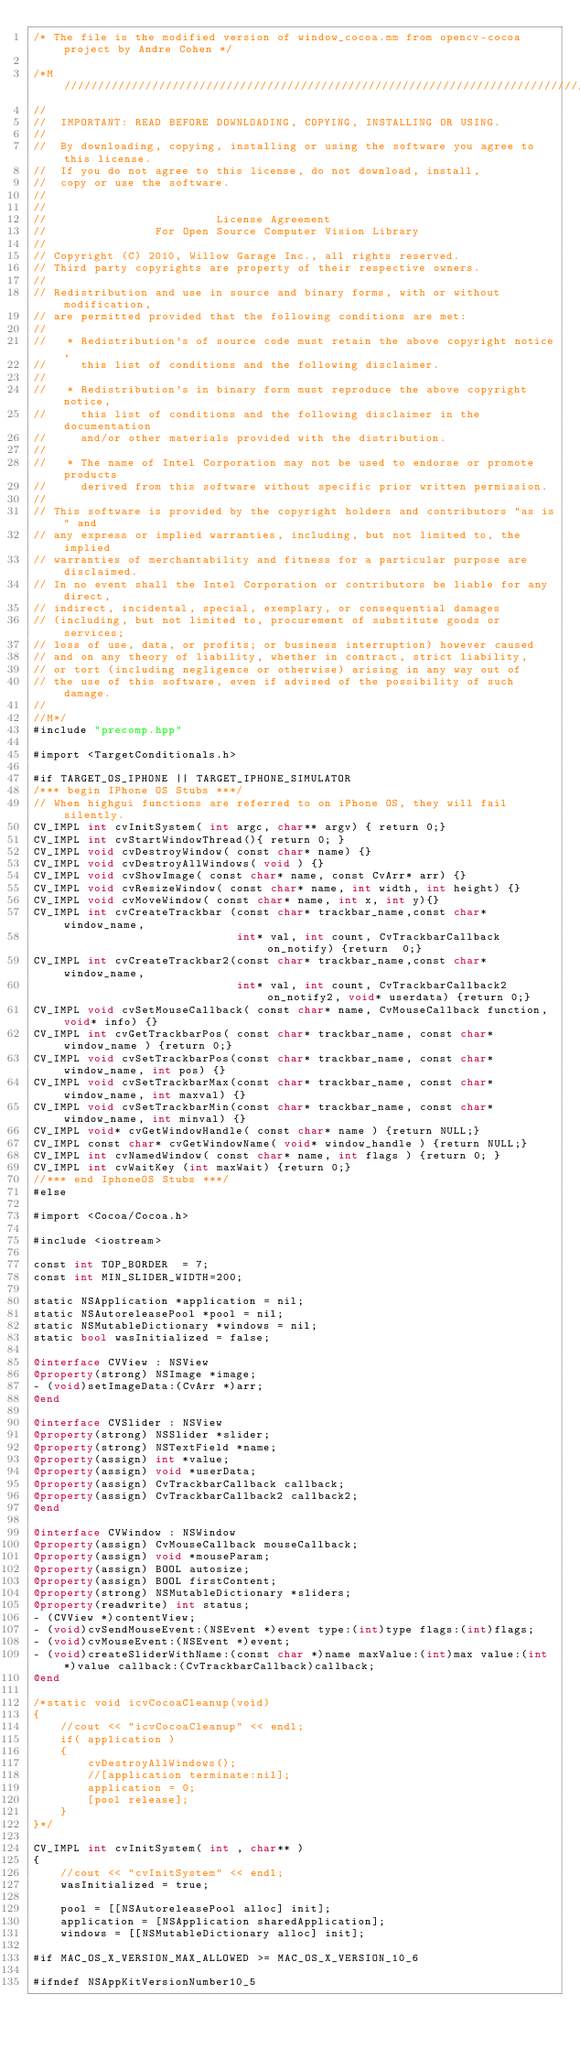<code> <loc_0><loc_0><loc_500><loc_500><_ObjectiveC_>/* The file is the modified version of window_cocoa.mm from opencv-cocoa project by Andre Cohen */

/*M///////////////////////////////////////////////////////////////////////////////////////
//
//  IMPORTANT: READ BEFORE DOWNLOADING, COPYING, INSTALLING OR USING.
//
//  By downloading, copying, installing or using the software you agree to this license.
//  If you do not agree to this license, do not download, install,
//  copy or use the software.
//
//
//                         License Agreement
//                For Open Source Computer Vision Library
//
// Copyright (C) 2010, Willow Garage Inc., all rights reserved.
// Third party copyrights are property of their respective owners.
//
// Redistribution and use in source and binary forms, with or without modification,
// are permitted provided that the following conditions are met:
//
//   * Redistribution's of source code must retain the above copyright notice,
//     this list of conditions and the following disclaimer.
//
//   * Redistribution's in binary form must reproduce the above copyright notice,
//     this list of conditions and the following disclaimer in the documentation
//     and/or other materials provided with the distribution.
//
//   * The name of Intel Corporation may not be used to endorse or promote products
//     derived from this software without specific prior written permission.
//
// This software is provided by the copyright holders and contributors "as is" and
// any express or implied warranties, including, but not limited to, the implied
// warranties of merchantability and fitness for a particular purpose are disclaimed.
// In no event shall the Intel Corporation or contributors be liable for any direct,
// indirect, incidental, special, exemplary, or consequential damages
// (including, but not limited to, procurement of substitute goods or services;
// loss of use, data, or profits; or business interruption) however caused
// and on any theory of liability, whether in contract, strict liability,
// or tort (including negligence or otherwise) arising in any way out of
// the use of this software, even if advised of the possibility of such damage.
//
//M*/
#include "precomp.hpp"

#import <TargetConditionals.h>

#if TARGET_OS_IPHONE || TARGET_IPHONE_SIMULATOR
/*** begin IPhone OS Stubs ***/
// When highgui functions are referred to on iPhone OS, they will fail silently.
CV_IMPL int cvInitSystem( int argc, char** argv) { return 0;}
CV_IMPL int cvStartWindowThread(){ return 0; }
CV_IMPL void cvDestroyWindow( const char* name) {}
CV_IMPL void cvDestroyAllWindows( void ) {}
CV_IMPL void cvShowImage( const char* name, const CvArr* arr) {}
CV_IMPL void cvResizeWindow( const char* name, int width, int height) {}
CV_IMPL void cvMoveWindow( const char* name, int x, int y){}
CV_IMPL int cvCreateTrackbar (const char* trackbar_name,const char* window_name,
                              int* val, int count, CvTrackbarCallback on_notify) {return  0;}
CV_IMPL int cvCreateTrackbar2(const char* trackbar_name,const char* window_name,
                              int* val, int count, CvTrackbarCallback2 on_notify2, void* userdata) {return 0;}
CV_IMPL void cvSetMouseCallback( const char* name, CvMouseCallback function, void* info) {}
CV_IMPL int cvGetTrackbarPos( const char* trackbar_name, const char* window_name ) {return 0;}
CV_IMPL void cvSetTrackbarPos(const char* trackbar_name, const char* window_name, int pos) {}
CV_IMPL void cvSetTrackbarMax(const char* trackbar_name, const char* window_name, int maxval) {}
CV_IMPL void cvSetTrackbarMin(const char* trackbar_name, const char* window_name, int minval) {}
CV_IMPL void* cvGetWindowHandle( const char* name ) {return NULL;}
CV_IMPL const char* cvGetWindowName( void* window_handle ) {return NULL;}
CV_IMPL int cvNamedWindow( const char* name, int flags ) {return 0; }
CV_IMPL int cvWaitKey (int maxWait) {return 0;}
//*** end IphoneOS Stubs ***/
#else

#import <Cocoa/Cocoa.h>

#include <iostream>

const int TOP_BORDER  = 7;
const int MIN_SLIDER_WIDTH=200;

static NSApplication *application = nil;
static NSAutoreleasePool *pool = nil;
static NSMutableDictionary *windows = nil;
static bool wasInitialized = false;

@interface CVView : NSView
@property(strong) NSImage *image;
- (void)setImageData:(CvArr *)arr;
@end

@interface CVSlider : NSView
@property(strong) NSSlider *slider;
@property(strong) NSTextField *name;
@property(assign) int *value;
@property(assign) void *userData;
@property(assign) CvTrackbarCallback callback;
@property(assign) CvTrackbarCallback2 callback2;
@end

@interface CVWindow : NSWindow
@property(assign) CvMouseCallback mouseCallback;
@property(assign) void *mouseParam;
@property(assign) BOOL autosize;
@property(assign) BOOL firstContent;
@property(strong) NSMutableDictionary *sliders;
@property(readwrite) int status;
- (CVView *)contentView;
- (void)cvSendMouseEvent:(NSEvent *)event type:(int)type flags:(int)flags;
- (void)cvMouseEvent:(NSEvent *)event;
- (void)createSliderWithName:(const char *)name maxValue:(int)max value:(int *)value callback:(CvTrackbarCallback)callback;
@end

/*static void icvCocoaCleanup(void)
{
    //cout << "icvCocoaCleanup" << endl;
    if( application )
    {
        cvDestroyAllWindows();
        //[application terminate:nil];
        application = 0;
        [pool release];
    }
}*/

CV_IMPL int cvInitSystem( int , char** )
{
    //cout << "cvInitSystem" << endl;
    wasInitialized = true;

    pool = [[NSAutoreleasePool alloc] init];
    application = [NSApplication sharedApplication];
    windows = [[NSMutableDictionary alloc] init];

#if MAC_OS_X_VERSION_MAX_ALLOWED >= MAC_OS_X_VERSION_10_6

#ifndef NSAppKitVersionNumber10_5</code> 